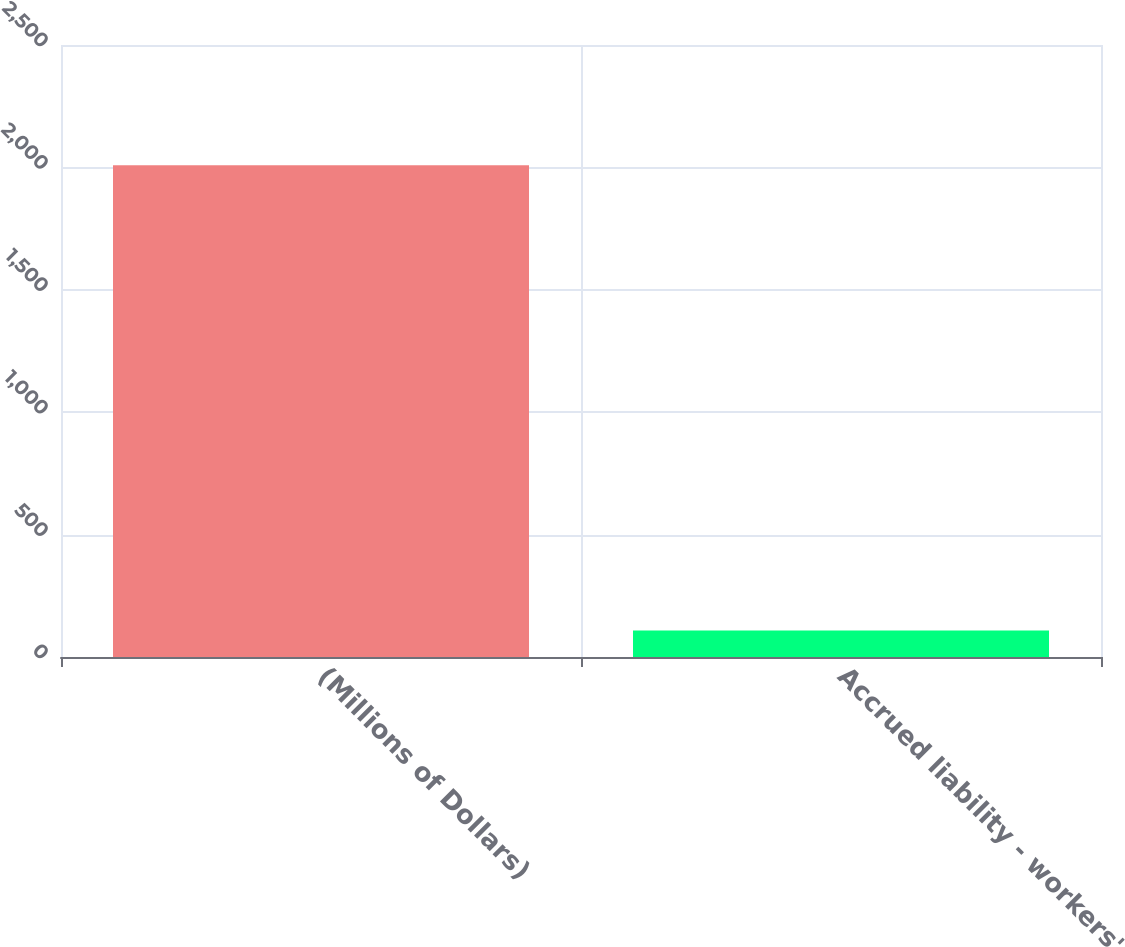Convert chart. <chart><loc_0><loc_0><loc_500><loc_500><bar_chart><fcel>(Millions of Dollars)<fcel>Accrued liability - workers'<nl><fcel>2009<fcel>108<nl></chart> 